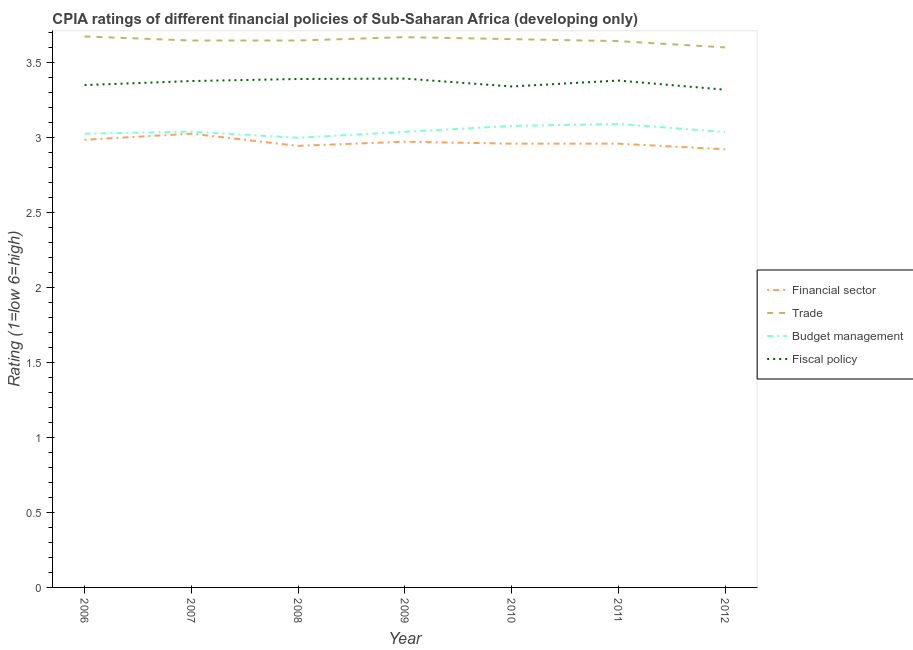How many different coloured lines are there?
Ensure brevity in your answer.  4. Is the number of lines equal to the number of legend labels?
Provide a short and direct response. Yes. What is the cpia rating of budget management in 2010?
Provide a short and direct response. 3.08. Across all years, what is the maximum cpia rating of financial sector?
Provide a succinct answer. 3.03. Across all years, what is the minimum cpia rating of financial sector?
Your response must be concise. 2.92. In which year was the cpia rating of fiscal policy maximum?
Keep it short and to the point. 2009. In which year was the cpia rating of budget management minimum?
Keep it short and to the point. 2008. What is the total cpia rating of financial sector in the graph?
Give a very brief answer. 20.78. What is the difference between the cpia rating of fiscal policy in 2007 and that in 2009?
Your response must be concise. -0.02. What is the difference between the cpia rating of trade in 2009 and the cpia rating of financial sector in 2010?
Your answer should be compact. 0.71. What is the average cpia rating of trade per year?
Offer a terse response. 3.65. In the year 2006, what is the difference between the cpia rating of fiscal policy and cpia rating of budget management?
Your response must be concise. 0.32. In how many years, is the cpia rating of budget management greater than 2.2?
Keep it short and to the point. 7. What is the ratio of the cpia rating of fiscal policy in 2009 to that in 2011?
Make the answer very short. 1. Is the cpia rating of financial sector in 2010 less than that in 2011?
Your response must be concise. No. Is the difference between the cpia rating of trade in 2006 and 2009 greater than the difference between the cpia rating of financial sector in 2006 and 2009?
Provide a succinct answer. No. What is the difference between the highest and the second highest cpia rating of fiscal policy?
Keep it short and to the point. 0. What is the difference between the highest and the lowest cpia rating of financial sector?
Give a very brief answer. 0.1. In how many years, is the cpia rating of trade greater than the average cpia rating of trade taken over all years?
Ensure brevity in your answer.  3. Is the sum of the cpia rating of financial sector in 2009 and 2010 greater than the maximum cpia rating of trade across all years?
Keep it short and to the point. Yes. Is the cpia rating of budget management strictly greater than the cpia rating of fiscal policy over the years?
Your answer should be compact. No. How many lines are there?
Offer a very short reply. 4. How many years are there in the graph?
Ensure brevity in your answer.  7. Does the graph contain grids?
Offer a terse response. No. Where does the legend appear in the graph?
Your answer should be very brief. Center right. What is the title of the graph?
Ensure brevity in your answer.  CPIA ratings of different financial policies of Sub-Saharan Africa (developing only). What is the label or title of the Y-axis?
Provide a short and direct response. Rating (1=low 6=high). What is the Rating (1=low 6=high) in Financial sector in 2006?
Provide a succinct answer. 2.99. What is the Rating (1=low 6=high) in Trade in 2006?
Provide a short and direct response. 3.68. What is the Rating (1=low 6=high) in Budget management in 2006?
Your answer should be very brief. 3.03. What is the Rating (1=low 6=high) of Fiscal policy in 2006?
Make the answer very short. 3.35. What is the Rating (1=low 6=high) of Financial sector in 2007?
Your response must be concise. 3.03. What is the Rating (1=low 6=high) in Trade in 2007?
Keep it short and to the point. 3.65. What is the Rating (1=low 6=high) in Budget management in 2007?
Your answer should be very brief. 3.04. What is the Rating (1=low 6=high) of Fiscal policy in 2007?
Your answer should be compact. 3.38. What is the Rating (1=low 6=high) of Financial sector in 2008?
Keep it short and to the point. 2.95. What is the Rating (1=low 6=high) of Trade in 2008?
Offer a very short reply. 3.65. What is the Rating (1=low 6=high) in Budget management in 2008?
Ensure brevity in your answer.  3. What is the Rating (1=low 6=high) of Fiscal policy in 2008?
Your answer should be very brief. 3.39. What is the Rating (1=low 6=high) of Financial sector in 2009?
Give a very brief answer. 2.97. What is the Rating (1=low 6=high) in Trade in 2009?
Your answer should be compact. 3.67. What is the Rating (1=low 6=high) in Budget management in 2009?
Ensure brevity in your answer.  3.04. What is the Rating (1=low 6=high) of Fiscal policy in 2009?
Offer a very short reply. 3.39. What is the Rating (1=low 6=high) in Financial sector in 2010?
Your answer should be very brief. 2.96. What is the Rating (1=low 6=high) of Trade in 2010?
Provide a succinct answer. 3.66. What is the Rating (1=low 6=high) in Budget management in 2010?
Offer a very short reply. 3.08. What is the Rating (1=low 6=high) of Fiscal policy in 2010?
Your answer should be very brief. 3.34. What is the Rating (1=low 6=high) in Financial sector in 2011?
Provide a succinct answer. 2.96. What is the Rating (1=low 6=high) of Trade in 2011?
Offer a very short reply. 3.64. What is the Rating (1=low 6=high) of Budget management in 2011?
Your answer should be very brief. 3.09. What is the Rating (1=low 6=high) in Fiscal policy in 2011?
Make the answer very short. 3.38. What is the Rating (1=low 6=high) in Financial sector in 2012?
Your answer should be compact. 2.92. What is the Rating (1=low 6=high) in Trade in 2012?
Your answer should be very brief. 3.6. What is the Rating (1=low 6=high) in Budget management in 2012?
Your answer should be very brief. 3.04. What is the Rating (1=low 6=high) in Fiscal policy in 2012?
Your answer should be compact. 3.32. Across all years, what is the maximum Rating (1=low 6=high) of Financial sector?
Your answer should be very brief. 3.03. Across all years, what is the maximum Rating (1=low 6=high) in Trade?
Make the answer very short. 3.68. Across all years, what is the maximum Rating (1=low 6=high) of Budget management?
Offer a very short reply. 3.09. Across all years, what is the maximum Rating (1=low 6=high) in Fiscal policy?
Keep it short and to the point. 3.39. Across all years, what is the minimum Rating (1=low 6=high) of Financial sector?
Your response must be concise. 2.92. Across all years, what is the minimum Rating (1=low 6=high) of Trade?
Make the answer very short. 3.6. Across all years, what is the minimum Rating (1=low 6=high) of Fiscal policy?
Make the answer very short. 3.32. What is the total Rating (1=low 6=high) of Financial sector in the graph?
Your answer should be very brief. 20.78. What is the total Rating (1=low 6=high) of Trade in the graph?
Offer a very short reply. 25.55. What is the total Rating (1=low 6=high) of Budget management in the graph?
Your response must be concise. 21.32. What is the total Rating (1=low 6=high) in Fiscal policy in the graph?
Offer a very short reply. 23.56. What is the difference between the Rating (1=low 6=high) of Financial sector in 2006 and that in 2007?
Make the answer very short. -0.04. What is the difference between the Rating (1=low 6=high) in Trade in 2006 and that in 2007?
Your answer should be very brief. 0.03. What is the difference between the Rating (1=low 6=high) of Budget management in 2006 and that in 2007?
Provide a succinct answer. -0.01. What is the difference between the Rating (1=low 6=high) of Fiscal policy in 2006 and that in 2007?
Offer a terse response. -0.03. What is the difference between the Rating (1=low 6=high) of Financial sector in 2006 and that in 2008?
Keep it short and to the point. 0.04. What is the difference between the Rating (1=low 6=high) of Trade in 2006 and that in 2008?
Provide a succinct answer. 0.03. What is the difference between the Rating (1=low 6=high) of Budget management in 2006 and that in 2008?
Ensure brevity in your answer.  0.03. What is the difference between the Rating (1=low 6=high) in Fiscal policy in 2006 and that in 2008?
Provide a short and direct response. -0.04. What is the difference between the Rating (1=low 6=high) of Financial sector in 2006 and that in 2009?
Keep it short and to the point. 0.01. What is the difference between the Rating (1=low 6=high) of Trade in 2006 and that in 2009?
Provide a short and direct response. 0. What is the difference between the Rating (1=low 6=high) in Budget management in 2006 and that in 2009?
Your response must be concise. -0.01. What is the difference between the Rating (1=low 6=high) of Fiscal policy in 2006 and that in 2009?
Make the answer very short. -0.04. What is the difference between the Rating (1=low 6=high) of Financial sector in 2006 and that in 2010?
Provide a short and direct response. 0.03. What is the difference between the Rating (1=low 6=high) of Trade in 2006 and that in 2010?
Provide a short and direct response. 0.02. What is the difference between the Rating (1=low 6=high) in Budget management in 2006 and that in 2010?
Offer a terse response. -0.05. What is the difference between the Rating (1=low 6=high) in Fiscal policy in 2006 and that in 2010?
Offer a very short reply. 0.01. What is the difference between the Rating (1=low 6=high) of Financial sector in 2006 and that in 2011?
Your answer should be compact. 0.03. What is the difference between the Rating (1=low 6=high) in Trade in 2006 and that in 2011?
Offer a terse response. 0.03. What is the difference between the Rating (1=low 6=high) of Budget management in 2006 and that in 2011?
Give a very brief answer. -0.07. What is the difference between the Rating (1=low 6=high) of Fiscal policy in 2006 and that in 2011?
Offer a terse response. -0.03. What is the difference between the Rating (1=low 6=high) in Financial sector in 2006 and that in 2012?
Offer a very short reply. 0.06. What is the difference between the Rating (1=low 6=high) of Trade in 2006 and that in 2012?
Ensure brevity in your answer.  0.07. What is the difference between the Rating (1=low 6=high) in Budget management in 2006 and that in 2012?
Provide a short and direct response. -0.01. What is the difference between the Rating (1=low 6=high) in Fiscal policy in 2006 and that in 2012?
Offer a terse response. 0.03. What is the difference between the Rating (1=low 6=high) in Financial sector in 2007 and that in 2008?
Ensure brevity in your answer.  0.08. What is the difference between the Rating (1=low 6=high) of Budget management in 2007 and that in 2008?
Offer a terse response. 0.04. What is the difference between the Rating (1=low 6=high) of Fiscal policy in 2007 and that in 2008?
Your response must be concise. -0.01. What is the difference between the Rating (1=low 6=high) in Financial sector in 2007 and that in 2009?
Make the answer very short. 0.05. What is the difference between the Rating (1=low 6=high) in Trade in 2007 and that in 2009?
Your response must be concise. -0.02. What is the difference between the Rating (1=low 6=high) of Budget management in 2007 and that in 2009?
Make the answer very short. 0. What is the difference between the Rating (1=low 6=high) in Fiscal policy in 2007 and that in 2009?
Give a very brief answer. -0.02. What is the difference between the Rating (1=low 6=high) of Financial sector in 2007 and that in 2010?
Your response must be concise. 0.07. What is the difference between the Rating (1=low 6=high) of Trade in 2007 and that in 2010?
Keep it short and to the point. -0.01. What is the difference between the Rating (1=low 6=high) in Budget management in 2007 and that in 2010?
Provide a short and direct response. -0.04. What is the difference between the Rating (1=low 6=high) in Fiscal policy in 2007 and that in 2010?
Your answer should be compact. 0.04. What is the difference between the Rating (1=low 6=high) of Financial sector in 2007 and that in 2011?
Your response must be concise. 0.07. What is the difference between the Rating (1=low 6=high) of Trade in 2007 and that in 2011?
Your answer should be very brief. 0. What is the difference between the Rating (1=low 6=high) in Budget management in 2007 and that in 2011?
Offer a very short reply. -0.05. What is the difference between the Rating (1=low 6=high) in Fiscal policy in 2007 and that in 2011?
Your answer should be compact. -0. What is the difference between the Rating (1=low 6=high) in Financial sector in 2007 and that in 2012?
Your answer should be very brief. 0.1. What is the difference between the Rating (1=low 6=high) of Trade in 2007 and that in 2012?
Your answer should be compact. 0.05. What is the difference between the Rating (1=low 6=high) in Budget management in 2007 and that in 2012?
Ensure brevity in your answer.  0. What is the difference between the Rating (1=low 6=high) of Fiscal policy in 2007 and that in 2012?
Your answer should be very brief. 0.06. What is the difference between the Rating (1=low 6=high) in Financial sector in 2008 and that in 2009?
Keep it short and to the point. -0.03. What is the difference between the Rating (1=low 6=high) in Trade in 2008 and that in 2009?
Ensure brevity in your answer.  -0.02. What is the difference between the Rating (1=low 6=high) in Budget management in 2008 and that in 2009?
Your answer should be very brief. -0.04. What is the difference between the Rating (1=low 6=high) in Fiscal policy in 2008 and that in 2009?
Keep it short and to the point. -0. What is the difference between the Rating (1=low 6=high) of Financial sector in 2008 and that in 2010?
Keep it short and to the point. -0.01. What is the difference between the Rating (1=low 6=high) of Trade in 2008 and that in 2010?
Make the answer very short. -0.01. What is the difference between the Rating (1=low 6=high) of Budget management in 2008 and that in 2010?
Provide a succinct answer. -0.08. What is the difference between the Rating (1=low 6=high) in Fiscal policy in 2008 and that in 2010?
Offer a very short reply. 0.05. What is the difference between the Rating (1=low 6=high) of Financial sector in 2008 and that in 2011?
Make the answer very short. -0.01. What is the difference between the Rating (1=low 6=high) of Trade in 2008 and that in 2011?
Make the answer very short. 0. What is the difference between the Rating (1=low 6=high) in Budget management in 2008 and that in 2011?
Give a very brief answer. -0.09. What is the difference between the Rating (1=low 6=high) of Fiscal policy in 2008 and that in 2011?
Provide a succinct answer. 0.01. What is the difference between the Rating (1=low 6=high) of Financial sector in 2008 and that in 2012?
Keep it short and to the point. 0.02. What is the difference between the Rating (1=low 6=high) of Trade in 2008 and that in 2012?
Your response must be concise. 0.05. What is the difference between the Rating (1=low 6=high) in Budget management in 2008 and that in 2012?
Ensure brevity in your answer.  -0.04. What is the difference between the Rating (1=low 6=high) of Fiscal policy in 2008 and that in 2012?
Offer a very short reply. 0.07. What is the difference between the Rating (1=low 6=high) in Financial sector in 2009 and that in 2010?
Make the answer very short. 0.01. What is the difference between the Rating (1=low 6=high) in Trade in 2009 and that in 2010?
Your response must be concise. 0.01. What is the difference between the Rating (1=low 6=high) in Budget management in 2009 and that in 2010?
Ensure brevity in your answer.  -0.04. What is the difference between the Rating (1=low 6=high) of Fiscal policy in 2009 and that in 2010?
Offer a terse response. 0.05. What is the difference between the Rating (1=low 6=high) in Financial sector in 2009 and that in 2011?
Provide a short and direct response. 0.01. What is the difference between the Rating (1=low 6=high) of Trade in 2009 and that in 2011?
Ensure brevity in your answer.  0.03. What is the difference between the Rating (1=low 6=high) in Budget management in 2009 and that in 2011?
Your answer should be very brief. -0.05. What is the difference between the Rating (1=low 6=high) of Fiscal policy in 2009 and that in 2011?
Provide a succinct answer. 0.01. What is the difference between the Rating (1=low 6=high) of Financial sector in 2009 and that in 2012?
Your answer should be compact. 0.05. What is the difference between the Rating (1=low 6=high) of Trade in 2009 and that in 2012?
Make the answer very short. 0.07. What is the difference between the Rating (1=low 6=high) in Fiscal policy in 2009 and that in 2012?
Ensure brevity in your answer.  0.07. What is the difference between the Rating (1=low 6=high) of Trade in 2010 and that in 2011?
Ensure brevity in your answer.  0.01. What is the difference between the Rating (1=low 6=high) of Budget management in 2010 and that in 2011?
Your response must be concise. -0.01. What is the difference between the Rating (1=low 6=high) of Fiscal policy in 2010 and that in 2011?
Provide a short and direct response. -0.04. What is the difference between the Rating (1=low 6=high) of Financial sector in 2010 and that in 2012?
Provide a short and direct response. 0.04. What is the difference between the Rating (1=low 6=high) in Trade in 2010 and that in 2012?
Provide a succinct answer. 0.06. What is the difference between the Rating (1=low 6=high) of Budget management in 2010 and that in 2012?
Keep it short and to the point. 0.04. What is the difference between the Rating (1=low 6=high) in Fiscal policy in 2010 and that in 2012?
Ensure brevity in your answer.  0.02. What is the difference between the Rating (1=low 6=high) in Financial sector in 2011 and that in 2012?
Offer a terse response. 0.04. What is the difference between the Rating (1=low 6=high) in Trade in 2011 and that in 2012?
Your response must be concise. 0.04. What is the difference between the Rating (1=low 6=high) of Budget management in 2011 and that in 2012?
Provide a succinct answer. 0.05. What is the difference between the Rating (1=low 6=high) of Fiscal policy in 2011 and that in 2012?
Keep it short and to the point. 0.06. What is the difference between the Rating (1=low 6=high) of Financial sector in 2006 and the Rating (1=low 6=high) of Trade in 2007?
Offer a terse response. -0.66. What is the difference between the Rating (1=low 6=high) of Financial sector in 2006 and the Rating (1=low 6=high) of Budget management in 2007?
Keep it short and to the point. -0.05. What is the difference between the Rating (1=low 6=high) of Financial sector in 2006 and the Rating (1=low 6=high) of Fiscal policy in 2007?
Give a very brief answer. -0.39. What is the difference between the Rating (1=low 6=high) in Trade in 2006 and the Rating (1=low 6=high) in Budget management in 2007?
Your response must be concise. 0.64. What is the difference between the Rating (1=low 6=high) in Trade in 2006 and the Rating (1=low 6=high) in Fiscal policy in 2007?
Your answer should be very brief. 0.3. What is the difference between the Rating (1=low 6=high) of Budget management in 2006 and the Rating (1=low 6=high) of Fiscal policy in 2007?
Offer a terse response. -0.35. What is the difference between the Rating (1=low 6=high) in Financial sector in 2006 and the Rating (1=low 6=high) in Trade in 2008?
Offer a terse response. -0.66. What is the difference between the Rating (1=low 6=high) of Financial sector in 2006 and the Rating (1=low 6=high) of Budget management in 2008?
Your response must be concise. -0.01. What is the difference between the Rating (1=low 6=high) in Financial sector in 2006 and the Rating (1=low 6=high) in Fiscal policy in 2008?
Keep it short and to the point. -0.41. What is the difference between the Rating (1=low 6=high) of Trade in 2006 and the Rating (1=low 6=high) of Budget management in 2008?
Ensure brevity in your answer.  0.68. What is the difference between the Rating (1=low 6=high) in Trade in 2006 and the Rating (1=low 6=high) in Fiscal policy in 2008?
Offer a terse response. 0.28. What is the difference between the Rating (1=low 6=high) of Budget management in 2006 and the Rating (1=low 6=high) of Fiscal policy in 2008?
Offer a very short reply. -0.36. What is the difference between the Rating (1=low 6=high) of Financial sector in 2006 and the Rating (1=low 6=high) of Trade in 2009?
Your answer should be compact. -0.68. What is the difference between the Rating (1=low 6=high) of Financial sector in 2006 and the Rating (1=low 6=high) of Budget management in 2009?
Offer a very short reply. -0.05. What is the difference between the Rating (1=low 6=high) in Financial sector in 2006 and the Rating (1=low 6=high) in Fiscal policy in 2009?
Your response must be concise. -0.41. What is the difference between the Rating (1=low 6=high) in Trade in 2006 and the Rating (1=low 6=high) in Budget management in 2009?
Keep it short and to the point. 0.64. What is the difference between the Rating (1=low 6=high) of Trade in 2006 and the Rating (1=low 6=high) of Fiscal policy in 2009?
Provide a short and direct response. 0.28. What is the difference between the Rating (1=low 6=high) in Budget management in 2006 and the Rating (1=low 6=high) in Fiscal policy in 2009?
Provide a short and direct response. -0.37. What is the difference between the Rating (1=low 6=high) of Financial sector in 2006 and the Rating (1=low 6=high) of Trade in 2010?
Provide a succinct answer. -0.67. What is the difference between the Rating (1=low 6=high) in Financial sector in 2006 and the Rating (1=low 6=high) in Budget management in 2010?
Provide a short and direct response. -0.09. What is the difference between the Rating (1=low 6=high) in Financial sector in 2006 and the Rating (1=low 6=high) in Fiscal policy in 2010?
Provide a succinct answer. -0.36. What is the difference between the Rating (1=low 6=high) in Trade in 2006 and the Rating (1=low 6=high) in Budget management in 2010?
Provide a short and direct response. 0.6. What is the difference between the Rating (1=low 6=high) of Trade in 2006 and the Rating (1=low 6=high) of Fiscal policy in 2010?
Keep it short and to the point. 0.33. What is the difference between the Rating (1=low 6=high) of Budget management in 2006 and the Rating (1=low 6=high) of Fiscal policy in 2010?
Your answer should be compact. -0.32. What is the difference between the Rating (1=low 6=high) in Financial sector in 2006 and the Rating (1=low 6=high) in Trade in 2011?
Provide a short and direct response. -0.66. What is the difference between the Rating (1=low 6=high) of Financial sector in 2006 and the Rating (1=low 6=high) of Budget management in 2011?
Provide a short and direct response. -0.11. What is the difference between the Rating (1=low 6=high) in Financial sector in 2006 and the Rating (1=low 6=high) in Fiscal policy in 2011?
Ensure brevity in your answer.  -0.4. What is the difference between the Rating (1=low 6=high) in Trade in 2006 and the Rating (1=low 6=high) in Budget management in 2011?
Your response must be concise. 0.58. What is the difference between the Rating (1=low 6=high) in Trade in 2006 and the Rating (1=low 6=high) in Fiscal policy in 2011?
Give a very brief answer. 0.29. What is the difference between the Rating (1=low 6=high) in Budget management in 2006 and the Rating (1=low 6=high) in Fiscal policy in 2011?
Provide a short and direct response. -0.35. What is the difference between the Rating (1=low 6=high) in Financial sector in 2006 and the Rating (1=low 6=high) in Trade in 2012?
Keep it short and to the point. -0.62. What is the difference between the Rating (1=low 6=high) in Financial sector in 2006 and the Rating (1=low 6=high) in Budget management in 2012?
Keep it short and to the point. -0.05. What is the difference between the Rating (1=low 6=high) of Financial sector in 2006 and the Rating (1=low 6=high) of Fiscal policy in 2012?
Keep it short and to the point. -0.33. What is the difference between the Rating (1=low 6=high) of Trade in 2006 and the Rating (1=low 6=high) of Budget management in 2012?
Your answer should be very brief. 0.64. What is the difference between the Rating (1=low 6=high) in Trade in 2006 and the Rating (1=low 6=high) in Fiscal policy in 2012?
Offer a terse response. 0.36. What is the difference between the Rating (1=low 6=high) of Budget management in 2006 and the Rating (1=low 6=high) of Fiscal policy in 2012?
Offer a terse response. -0.29. What is the difference between the Rating (1=low 6=high) in Financial sector in 2007 and the Rating (1=low 6=high) in Trade in 2008?
Offer a very short reply. -0.62. What is the difference between the Rating (1=low 6=high) in Financial sector in 2007 and the Rating (1=low 6=high) in Budget management in 2008?
Provide a short and direct response. 0.03. What is the difference between the Rating (1=low 6=high) in Financial sector in 2007 and the Rating (1=low 6=high) in Fiscal policy in 2008?
Your answer should be compact. -0.36. What is the difference between the Rating (1=low 6=high) of Trade in 2007 and the Rating (1=low 6=high) of Budget management in 2008?
Provide a succinct answer. 0.65. What is the difference between the Rating (1=low 6=high) in Trade in 2007 and the Rating (1=low 6=high) in Fiscal policy in 2008?
Make the answer very short. 0.26. What is the difference between the Rating (1=low 6=high) of Budget management in 2007 and the Rating (1=low 6=high) of Fiscal policy in 2008?
Offer a terse response. -0.35. What is the difference between the Rating (1=low 6=high) in Financial sector in 2007 and the Rating (1=low 6=high) in Trade in 2009?
Give a very brief answer. -0.64. What is the difference between the Rating (1=low 6=high) of Financial sector in 2007 and the Rating (1=low 6=high) of Budget management in 2009?
Give a very brief answer. -0.01. What is the difference between the Rating (1=low 6=high) of Financial sector in 2007 and the Rating (1=low 6=high) of Fiscal policy in 2009?
Ensure brevity in your answer.  -0.37. What is the difference between the Rating (1=low 6=high) in Trade in 2007 and the Rating (1=low 6=high) in Budget management in 2009?
Your answer should be compact. 0.61. What is the difference between the Rating (1=low 6=high) in Trade in 2007 and the Rating (1=low 6=high) in Fiscal policy in 2009?
Your answer should be very brief. 0.25. What is the difference between the Rating (1=low 6=high) in Budget management in 2007 and the Rating (1=low 6=high) in Fiscal policy in 2009?
Offer a terse response. -0.35. What is the difference between the Rating (1=low 6=high) in Financial sector in 2007 and the Rating (1=low 6=high) in Trade in 2010?
Give a very brief answer. -0.63. What is the difference between the Rating (1=low 6=high) in Financial sector in 2007 and the Rating (1=low 6=high) in Budget management in 2010?
Give a very brief answer. -0.05. What is the difference between the Rating (1=low 6=high) in Financial sector in 2007 and the Rating (1=low 6=high) in Fiscal policy in 2010?
Your response must be concise. -0.32. What is the difference between the Rating (1=low 6=high) in Trade in 2007 and the Rating (1=low 6=high) in Budget management in 2010?
Your answer should be very brief. 0.57. What is the difference between the Rating (1=low 6=high) in Trade in 2007 and the Rating (1=low 6=high) in Fiscal policy in 2010?
Your response must be concise. 0.31. What is the difference between the Rating (1=low 6=high) in Budget management in 2007 and the Rating (1=low 6=high) in Fiscal policy in 2010?
Keep it short and to the point. -0.3. What is the difference between the Rating (1=low 6=high) in Financial sector in 2007 and the Rating (1=low 6=high) in Trade in 2011?
Ensure brevity in your answer.  -0.62. What is the difference between the Rating (1=low 6=high) of Financial sector in 2007 and the Rating (1=low 6=high) of Budget management in 2011?
Provide a short and direct response. -0.07. What is the difference between the Rating (1=low 6=high) of Financial sector in 2007 and the Rating (1=low 6=high) of Fiscal policy in 2011?
Your answer should be compact. -0.35. What is the difference between the Rating (1=low 6=high) in Trade in 2007 and the Rating (1=low 6=high) in Budget management in 2011?
Offer a terse response. 0.56. What is the difference between the Rating (1=low 6=high) in Trade in 2007 and the Rating (1=low 6=high) in Fiscal policy in 2011?
Make the answer very short. 0.27. What is the difference between the Rating (1=low 6=high) in Budget management in 2007 and the Rating (1=low 6=high) in Fiscal policy in 2011?
Your answer should be compact. -0.34. What is the difference between the Rating (1=low 6=high) in Financial sector in 2007 and the Rating (1=low 6=high) in Trade in 2012?
Your answer should be compact. -0.58. What is the difference between the Rating (1=low 6=high) of Financial sector in 2007 and the Rating (1=low 6=high) of Budget management in 2012?
Offer a very short reply. -0.01. What is the difference between the Rating (1=low 6=high) of Financial sector in 2007 and the Rating (1=low 6=high) of Fiscal policy in 2012?
Make the answer very short. -0.29. What is the difference between the Rating (1=low 6=high) in Trade in 2007 and the Rating (1=low 6=high) in Budget management in 2012?
Keep it short and to the point. 0.61. What is the difference between the Rating (1=low 6=high) of Trade in 2007 and the Rating (1=low 6=high) of Fiscal policy in 2012?
Provide a succinct answer. 0.33. What is the difference between the Rating (1=low 6=high) in Budget management in 2007 and the Rating (1=low 6=high) in Fiscal policy in 2012?
Provide a short and direct response. -0.28. What is the difference between the Rating (1=low 6=high) in Financial sector in 2008 and the Rating (1=low 6=high) in Trade in 2009?
Your answer should be compact. -0.73. What is the difference between the Rating (1=low 6=high) in Financial sector in 2008 and the Rating (1=low 6=high) in Budget management in 2009?
Your answer should be very brief. -0.09. What is the difference between the Rating (1=low 6=high) of Financial sector in 2008 and the Rating (1=low 6=high) of Fiscal policy in 2009?
Your response must be concise. -0.45. What is the difference between the Rating (1=low 6=high) of Trade in 2008 and the Rating (1=low 6=high) of Budget management in 2009?
Ensure brevity in your answer.  0.61. What is the difference between the Rating (1=low 6=high) in Trade in 2008 and the Rating (1=low 6=high) in Fiscal policy in 2009?
Offer a very short reply. 0.25. What is the difference between the Rating (1=low 6=high) of Budget management in 2008 and the Rating (1=low 6=high) of Fiscal policy in 2009?
Offer a very short reply. -0.39. What is the difference between the Rating (1=low 6=high) in Financial sector in 2008 and the Rating (1=low 6=high) in Trade in 2010?
Offer a very short reply. -0.71. What is the difference between the Rating (1=low 6=high) of Financial sector in 2008 and the Rating (1=low 6=high) of Budget management in 2010?
Provide a short and direct response. -0.13. What is the difference between the Rating (1=low 6=high) of Financial sector in 2008 and the Rating (1=low 6=high) of Fiscal policy in 2010?
Provide a succinct answer. -0.4. What is the difference between the Rating (1=low 6=high) in Trade in 2008 and the Rating (1=low 6=high) in Budget management in 2010?
Keep it short and to the point. 0.57. What is the difference between the Rating (1=low 6=high) in Trade in 2008 and the Rating (1=low 6=high) in Fiscal policy in 2010?
Provide a short and direct response. 0.31. What is the difference between the Rating (1=low 6=high) in Budget management in 2008 and the Rating (1=low 6=high) in Fiscal policy in 2010?
Your answer should be compact. -0.34. What is the difference between the Rating (1=low 6=high) of Financial sector in 2008 and the Rating (1=low 6=high) of Trade in 2011?
Provide a succinct answer. -0.7. What is the difference between the Rating (1=low 6=high) of Financial sector in 2008 and the Rating (1=low 6=high) of Budget management in 2011?
Offer a terse response. -0.15. What is the difference between the Rating (1=low 6=high) in Financial sector in 2008 and the Rating (1=low 6=high) in Fiscal policy in 2011?
Make the answer very short. -0.44. What is the difference between the Rating (1=low 6=high) of Trade in 2008 and the Rating (1=low 6=high) of Budget management in 2011?
Your answer should be very brief. 0.56. What is the difference between the Rating (1=low 6=high) in Trade in 2008 and the Rating (1=low 6=high) in Fiscal policy in 2011?
Give a very brief answer. 0.27. What is the difference between the Rating (1=low 6=high) in Budget management in 2008 and the Rating (1=low 6=high) in Fiscal policy in 2011?
Keep it short and to the point. -0.38. What is the difference between the Rating (1=low 6=high) in Financial sector in 2008 and the Rating (1=low 6=high) in Trade in 2012?
Provide a short and direct response. -0.66. What is the difference between the Rating (1=low 6=high) in Financial sector in 2008 and the Rating (1=low 6=high) in Budget management in 2012?
Your answer should be compact. -0.09. What is the difference between the Rating (1=low 6=high) of Financial sector in 2008 and the Rating (1=low 6=high) of Fiscal policy in 2012?
Offer a very short reply. -0.37. What is the difference between the Rating (1=low 6=high) of Trade in 2008 and the Rating (1=low 6=high) of Budget management in 2012?
Your answer should be compact. 0.61. What is the difference between the Rating (1=low 6=high) in Trade in 2008 and the Rating (1=low 6=high) in Fiscal policy in 2012?
Provide a short and direct response. 0.33. What is the difference between the Rating (1=low 6=high) in Budget management in 2008 and the Rating (1=low 6=high) in Fiscal policy in 2012?
Offer a terse response. -0.32. What is the difference between the Rating (1=low 6=high) in Financial sector in 2009 and the Rating (1=low 6=high) in Trade in 2010?
Your response must be concise. -0.68. What is the difference between the Rating (1=low 6=high) of Financial sector in 2009 and the Rating (1=low 6=high) of Budget management in 2010?
Offer a terse response. -0.11. What is the difference between the Rating (1=low 6=high) in Financial sector in 2009 and the Rating (1=low 6=high) in Fiscal policy in 2010?
Provide a short and direct response. -0.37. What is the difference between the Rating (1=low 6=high) of Trade in 2009 and the Rating (1=low 6=high) of Budget management in 2010?
Offer a terse response. 0.59. What is the difference between the Rating (1=low 6=high) of Trade in 2009 and the Rating (1=low 6=high) of Fiscal policy in 2010?
Offer a terse response. 0.33. What is the difference between the Rating (1=low 6=high) of Budget management in 2009 and the Rating (1=low 6=high) of Fiscal policy in 2010?
Provide a succinct answer. -0.3. What is the difference between the Rating (1=low 6=high) in Financial sector in 2009 and the Rating (1=low 6=high) in Trade in 2011?
Provide a short and direct response. -0.67. What is the difference between the Rating (1=low 6=high) in Financial sector in 2009 and the Rating (1=low 6=high) in Budget management in 2011?
Give a very brief answer. -0.12. What is the difference between the Rating (1=low 6=high) in Financial sector in 2009 and the Rating (1=low 6=high) in Fiscal policy in 2011?
Offer a very short reply. -0.41. What is the difference between the Rating (1=low 6=high) in Trade in 2009 and the Rating (1=low 6=high) in Budget management in 2011?
Provide a short and direct response. 0.58. What is the difference between the Rating (1=low 6=high) in Trade in 2009 and the Rating (1=low 6=high) in Fiscal policy in 2011?
Ensure brevity in your answer.  0.29. What is the difference between the Rating (1=low 6=high) of Budget management in 2009 and the Rating (1=low 6=high) of Fiscal policy in 2011?
Offer a terse response. -0.34. What is the difference between the Rating (1=low 6=high) of Financial sector in 2009 and the Rating (1=low 6=high) of Trade in 2012?
Keep it short and to the point. -0.63. What is the difference between the Rating (1=low 6=high) in Financial sector in 2009 and the Rating (1=low 6=high) in Budget management in 2012?
Your answer should be very brief. -0.06. What is the difference between the Rating (1=low 6=high) of Financial sector in 2009 and the Rating (1=low 6=high) of Fiscal policy in 2012?
Keep it short and to the point. -0.35. What is the difference between the Rating (1=low 6=high) in Trade in 2009 and the Rating (1=low 6=high) in Budget management in 2012?
Your answer should be very brief. 0.63. What is the difference between the Rating (1=low 6=high) in Trade in 2009 and the Rating (1=low 6=high) in Fiscal policy in 2012?
Offer a terse response. 0.35. What is the difference between the Rating (1=low 6=high) of Budget management in 2009 and the Rating (1=low 6=high) of Fiscal policy in 2012?
Provide a short and direct response. -0.28. What is the difference between the Rating (1=low 6=high) of Financial sector in 2010 and the Rating (1=low 6=high) of Trade in 2011?
Your answer should be compact. -0.68. What is the difference between the Rating (1=low 6=high) of Financial sector in 2010 and the Rating (1=low 6=high) of Budget management in 2011?
Ensure brevity in your answer.  -0.13. What is the difference between the Rating (1=low 6=high) of Financial sector in 2010 and the Rating (1=low 6=high) of Fiscal policy in 2011?
Keep it short and to the point. -0.42. What is the difference between the Rating (1=low 6=high) of Trade in 2010 and the Rating (1=low 6=high) of Budget management in 2011?
Give a very brief answer. 0.57. What is the difference between the Rating (1=low 6=high) of Trade in 2010 and the Rating (1=low 6=high) of Fiscal policy in 2011?
Provide a succinct answer. 0.28. What is the difference between the Rating (1=low 6=high) of Budget management in 2010 and the Rating (1=low 6=high) of Fiscal policy in 2011?
Your answer should be compact. -0.3. What is the difference between the Rating (1=low 6=high) in Financial sector in 2010 and the Rating (1=low 6=high) in Trade in 2012?
Your response must be concise. -0.64. What is the difference between the Rating (1=low 6=high) of Financial sector in 2010 and the Rating (1=low 6=high) of Budget management in 2012?
Ensure brevity in your answer.  -0.08. What is the difference between the Rating (1=low 6=high) in Financial sector in 2010 and the Rating (1=low 6=high) in Fiscal policy in 2012?
Offer a terse response. -0.36. What is the difference between the Rating (1=low 6=high) of Trade in 2010 and the Rating (1=low 6=high) of Budget management in 2012?
Keep it short and to the point. 0.62. What is the difference between the Rating (1=low 6=high) in Trade in 2010 and the Rating (1=low 6=high) in Fiscal policy in 2012?
Provide a succinct answer. 0.34. What is the difference between the Rating (1=low 6=high) in Budget management in 2010 and the Rating (1=low 6=high) in Fiscal policy in 2012?
Make the answer very short. -0.24. What is the difference between the Rating (1=low 6=high) in Financial sector in 2011 and the Rating (1=low 6=high) in Trade in 2012?
Offer a terse response. -0.64. What is the difference between the Rating (1=low 6=high) in Financial sector in 2011 and the Rating (1=low 6=high) in Budget management in 2012?
Your answer should be very brief. -0.08. What is the difference between the Rating (1=low 6=high) in Financial sector in 2011 and the Rating (1=low 6=high) in Fiscal policy in 2012?
Offer a very short reply. -0.36. What is the difference between the Rating (1=low 6=high) of Trade in 2011 and the Rating (1=low 6=high) of Budget management in 2012?
Provide a short and direct response. 0.61. What is the difference between the Rating (1=low 6=high) of Trade in 2011 and the Rating (1=low 6=high) of Fiscal policy in 2012?
Keep it short and to the point. 0.32. What is the difference between the Rating (1=low 6=high) of Budget management in 2011 and the Rating (1=low 6=high) of Fiscal policy in 2012?
Your answer should be very brief. -0.23. What is the average Rating (1=low 6=high) in Financial sector per year?
Make the answer very short. 2.97. What is the average Rating (1=low 6=high) of Trade per year?
Keep it short and to the point. 3.65. What is the average Rating (1=low 6=high) in Budget management per year?
Make the answer very short. 3.05. What is the average Rating (1=low 6=high) of Fiscal policy per year?
Your answer should be very brief. 3.37. In the year 2006, what is the difference between the Rating (1=low 6=high) in Financial sector and Rating (1=low 6=high) in Trade?
Provide a succinct answer. -0.69. In the year 2006, what is the difference between the Rating (1=low 6=high) of Financial sector and Rating (1=low 6=high) of Budget management?
Give a very brief answer. -0.04. In the year 2006, what is the difference between the Rating (1=low 6=high) of Financial sector and Rating (1=low 6=high) of Fiscal policy?
Keep it short and to the point. -0.36. In the year 2006, what is the difference between the Rating (1=low 6=high) of Trade and Rating (1=low 6=high) of Budget management?
Your response must be concise. 0.65. In the year 2006, what is the difference between the Rating (1=low 6=high) in Trade and Rating (1=low 6=high) in Fiscal policy?
Keep it short and to the point. 0.32. In the year 2006, what is the difference between the Rating (1=low 6=high) of Budget management and Rating (1=low 6=high) of Fiscal policy?
Your answer should be compact. -0.32. In the year 2007, what is the difference between the Rating (1=low 6=high) in Financial sector and Rating (1=low 6=high) in Trade?
Provide a short and direct response. -0.62. In the year 2007, what is the difference between the Rating (1=low 6=high) of Financial sector and Rating (1=low 6=high) of Budget management?
Your answer should be very brief. -0.01. In the year 2007, what is the difference between the Rating (1=low 6=high) of Financial sector and Rating (1=low 6=high) of Fiscal policy?
Offer a very short reply. -0.35. In the year 2007, what is the difference between the Rating (1=low 6=high) of Trade and Rating (1=low 6=high) of Budget management?
Ensure brevity in your answer.  0.61. In the year 2007, what is the difference between the Rating (1=low 6=high) in Trade and Rating (1=low 6=high) in Fiscal policy?
Your response must be concise. 0.27. In the year 2007, what is the difference between the Rating (1=low 6=high) in Budget management and Rating (1=low 6=high) in Fiscal policy?
Your answer should be very brief. -0.34. In the year 2008, what is the difference between the Rating (1=low 6=high) of Financial sector and Rating (1=low 6=high) of Trade?
Provide a short and direct response. -0.7. In the year 2008, what is the difference between the Rating (1=low 6=high) in Financial sector and Rating (1=low 6=high) in Budget management?
Provide a short and direct response. -0.05. In the year 2008, what is the difference between the Rating (1=low 6=high) in Financial sector and Rating (1=low 6=high) in Fiscal policy?
Offer a very short reply. -0.45. In the year 2008, what is the difference between the Rating (1=low 6=high) in Trade and Rating (1=low 6=high) in Budget management?
Your answer should be very brief. 0.65. In the year 2008, what is the difference between the Rating (1=low 6=high) in Trade and Rating (1=low 6=high) in Fiscal policy?
Your answer should be compact. 0.26. In the year 2008, what is the difference between the Rating (1=low 6=high) in Budget management and Rating (1=low 6=high) in Fiscal policy?
Ensure brevity in your answer.  -0.39. In the year 2009, what is the difference between the Rating (1=low 6=high) of Financial sector and Rating (1=low 6=high) of Trade?
Your response must be concise. -0.7. In the year 2009, what is the difference between the Rating (1=low 6=high) of Financial sector and Rating (1=low 6=high) of Budget management?
Your answer should be very brief. -0.07. In the year 2009, what is the difference between the Rating (1=low 6=high) in Financial sector and Rating (1=low 6=high) in Fiscal policy?
Make the answer very short. -0.42. In the year 2009, what is the difference between the Rating (1=low 6=high) in Trade and Rating (1=low 6=high) in Budget management?
Offer a terse response. 0.63. In the year 2009, what is the difference between the Rating (1=low 6=high) of Trade and Rating (1=low 6=high) of Fiscal policy?
Your answer should be compact. 0.28. In the year 2009, what is the difference between the Rating (1=low 6=high) in Budget management and Rating (1=low 6=high) in Fiscal policy?
Your answer should be compact. -0.36. In the year 2010, what is the difference between the Rating (1=low 6=high) in Financial sector and Rating (1=low 6=high) in Trade?
Ensure brevity in your answer.  -0.7. In the year 2010, what is the difference between the Rating (1=low 6=high) in Financial sector and Rating (1=low 6=high) in Budget management?
Offer a very short reply. -0.12. In the year 2010, what is the difference between the Rating (1=low 6=high) in Financial sector and Rating (1=low 6=high) in Fiscal policy?
Your response must be concise. -0.38. In the year 2010, what is the difference between the Rating (1=low 6=high) of Trade and Rating (1=low 6=high) of Budget management?
Your response must be concise. 0.58. In the year 2010, what is the difference between the Rating (1=low 6=high) of Trade and Rating (1=low 6=high) of Fiscal policy?
Offer a very short reply. 0.32. In the year 2010, what is the difference between the Rating (1=low 6=high) in Budget management and Rating (1=low 6=high) in Fiscal policy?
Your response must be concise. -0.26. In the year 2011, what is the difference between the Rating (1=low 6=high) of Financial sector and Rating (1=low 6=high) of Trade?
Provide a short and direct response. -0.68. In the year 2011, what is the difference between the Rating (1=low 6=high) in Financial sector and Rating (1=low 6=high) in Budget management?
Keep it short and to the point. -0.13. In the year 2011, what is the difference between the Rating (1=low 6=high) in Financial sector and Rating (1=low 6=high) in Fiscal policy?
Your answer should be very brief. -0.42. In the year 2011, what is the difference between the Rating (1=low 6=high) of Trade and Rating (1=low 6=high) of Budget management?
Make the answer very short. 0.55. In the year 2011, what is the difference between the Rating (1=low 6=high) of Trade and Rating (1=low 6=high) of Fiscal policy?
Your answer should be very brief. 0.26. In the year 2011, what is the difference between the Rating (1=low 6=high) in Budget management and Rating (1=low 6=high) in Fiscal policy?
Give a very brief answer. -0.29. In the year 2012, what is the difference between the Rating (1=low 6=high) of Financial sector and Rating (1=low 6=high) of Trade?
Offer a very short reply. -0.68. In the year 2012, what is the difference between the Rating (1=low 6=high) of Financial sector and Rating (1=low 6=high) of Budget management?
Give a very brief answer. -0.12. In the year 2012, what is the difference between the Rating (1=low 6=high) of Financial sector and Rating (1=low 6=high) of Fiscal policy?
Keep it short and to the point. -0.4. In the year 2012, what is the difference between the Rating (1=low 6=high) in Trade and Rating (1=low 6=high) in Budget management?
Keep it short and to the point. 0.56. In the year 2012, what is the difference between the Rating (1=low 6=high) in Trade and Rating (1=low 6=high) in Fiscal policy?
Offer a terse response. 0.28. In the year 2012, what is the difference between the Rating (1=low 6=high) of Budget management and Rating (1=low 6=high) of Fiscal policy?
Your response must be concise. -0.28. What is the ratio of the Rating (1=low 6=high) of Financial sector in 2006 to that in 2007?
Make the answer very short. 0.99. What is the ratio of the Rating (1=low 6=high) of Trade in 2006 to that in 2007?
Your answer should be very brief. 1.01. What is the ratio of the Rating (1=low 6=high) in Financial sector in 2006 to that in 2008?
Keep it short and to the point. 1.01. What is the ratio of the Rating (1=low 6=high) of Trade in 2006 to that in 2008?
Offer a very short reply. 1.01. What is the ratio of the Rating (1=low 6=high) of Budget management in 2006 to that in 2008?
Provide a succinct answer. 1.01. What is the ratio of the Rating (1=low 6=high) in Financial sector in 2006 to that in 2009?
Your response must be concise. 1. What is the ratio of the Rating (1=low 6=high) of Fiscal policy in 2006 to that in 2009?
Offer a very short reply. 0.99. What is the ratio of the Rating (1=low 6=high) in Financial sector in 2006 to that in 2010?
Offer a terse response. 1.01. What is the ratio of the Rating (1=low 6=high) of Budget management in 2006 to that in 2010?
Offer a terse response. 0.98. What is the ratio of the Rating (1=low 6=high) in Financial sector in 2006 to that in 2011?
Give a very brief answer. 1.01. What is the ratio of the Rating (1=low 6=high) in Trade in 2006 to that in 2011?
Keep it short and to the point. 1.01. What is the ratio of the Rating (1=low 6=high) of Financial sector in 2006 to that in 2012?
Provide a succinct answer. 1.02. What is the ratio of the Rating (1=low 6=high) in Trade in 2006 to that in 2012?
Offer a terse response. 1.02. What is the ratio of the Rating (1=low 6=high) in Budget management in 2006 to that in 2012?
Your response must be concise. 1. What is the ratio of the Rating (1=low 6=high) of Fiscal policy in 2006 to that in 2012?
Ensure brevity in your answer.  1.01. What is the ratio of the Rating (1=low 6=high) in Financial sector in 2007 to that in 2008?
Offer a terse response. 1.03. What is the ratio of the Rating (1=low 6=high) in Budget management in 2007 to that in 2008?
Your answer should be compact. 1.01. What is the ratio of the Rating (1=low 6=high) in Financial sector in 2007 to that in 2009?
Ensure brevity in your answer.  1.02. What is the ratio of the Rating (1=low 6=high) in Budget management in 2007 to that in 2009?
Give a very brief answer. 1. What is the ratio of the Rating (1=low 6=high) of Fiscal policy in 2007 to that in 2009?
Offer a terse response. 1. What is the ratio of the Rating (1=low 6=high) in Financial sector in 2007 to that in 2010?
Give a very brief answer. 1.02. What is the ratio of the Rating (1=low 6=high) in Trade in 2007 to that in 2010?
Give a very brief answer. 1. What is the ratio of the Rating (1=low 6=high) in Budget management in 2007 to that in 2010?
Offer a very short reply. 0.99. What is the ratio of the Rating (1=low 6=high) of Fiscal policy in 2007 to that in 2010?
Give a very brief answer. 1.01. What is the ratio of the Rating (1=low 6=high) in Financial sector in 2007 to that in 2011?
Provide a succinct answer. 1.02. What is the ratio of the Rating (1=low 6=high) in Trade in 2007 to that in 2011?
Offer a very short reply. 1. What is the ratio of the Rating (1=low 6=high) in Budget management in 2007 to that in 2011?
Your answer should be compact. 0.98. What is the ratio of the Rating (1=low 6=high) of Fiscal policy in 2007 to that in 2011?
Your answer should be very brief. 1. What is the ratio of the Rating (1=low 6=high) of Financial sector in 2007 to that in 2012?
Provide a succinct answer. 1.04. What is the ratio of the Rating (1=low 6=high) of Trade in 2007 to that in 2012?
Keep it short and to the point. 1.01. What is the ratio of the Rating (1=low 6=high) of Fiscal policy in 2007 to that in 2012?
Offer a terse response. 1.02. What is the ratio of the Rating (1=low 6=high) in Trade in 2008 to that in 2009?
Make the answer very short. 0.99. What is the ratio of the Rating (1=low 6=high) of Budget management in 2008 to that in 2010?
Offer a very short reply. 0.97. What is the ratio of the Rating (1=low 6=high) of Fiscal policy in 2008 to that in 2010?
Ensure brevity in your answer.  1.01. What is the ratio of the Rating (1=low 6=high) of Budget management in 2008 to that in 2011?
Ensure brevity in your answer.  0.97. What is the ratio of the Rating (1=low 6=high) in Trade in 2008 to that in 2012?
Provide a succinct answer. 1.01. What is the ratio of the Rating (1=low 6=high) in Budget management in 2008 to that in 2012?
Provide a short and direct response. 0.99. What is the ratio of the Rating (1=low 6=high) in Fiscal policy in 2008 to that in 2012?
Give a very brief answer. 1.02. What is the ratio of the Rating (1=low 6=high) in Financial sector in 2009 to that in 2010?
Ensure brevity in your answer.  1. What is the ratio of the Rating (1=low 6=high) of Budget management in 2009 to that in 2010?
Provide a short and direct response. 0.99. What is the ratio of the Rating (1=low 6=high) of Fiscal policy in 2009 to that in 2010?
Provide a succinct answer. 1.02. What is the ratio of the Rating (1=low 6=high) of Trade in 2009 to that in 2011?
Make the answer very short. 1.01. What is the ratio of the Rating (1=low 6=high) in Budget management in 2009 to that in 2011?
Give a very brief answer. 0.98. What is the ratio of the Rating (1=low 6=high) of Financial sector in 2009 to that in 2012?
Ensure brevity in your answer.  1.02. What is the ratio of the Rating (1=low 6=high) in Trade in 2009 to that in 2012?
Provide a short and direct response. 1.02. What is the ratio of the Rating (1=low 6=high) of Budget management in 2009 to that in 2012?
Offer a terse response. 1. What is the ratio of the Rating (1=low 6=high) in Fiscal policy in 2009 to that in 2012?
Ensure brevity in your answer.  1.02. What is the ratio of the Rating (1=low 6=high) in Financial sector in 2010 to that in 2011?
Provide a succinct answer. 1. What is the ratio of the Rating (1=low 6=high) in Trade in 2010 to that in 2011?
Give a very brief answer. 1. What is the ratio of the Rating (1=low 6=high) in Budget management in 2010 to that in 2011?
Offer a terse response. 1. What is the ratio of the Rating (1=low 6=high) in Fiscal policy in 2010 to that in 2011?
Offer a terse response. 0.99. What is the ratio of the Rating (1=low 6=high) in Financial sector in 2010 to that in 2012?
Ensure brevity in your answer.  1.01. What is the ratio of the Rating (1=low 6=high) of Trade in 2010 to that in 2012?
Your answer should be very brief. 1.02. What is the ratio of the Rating (1=low 6=high) in Budget management in 2010 to that in 2012?
Your answer should be very brief. 1.01. What is the ratio of the Rating (1=low 6=high) in Financial sector in 2011 to that in 2012?
Your answer should be compact. 1.01. What is the ratio of the Rating (1=low 6=high) in Trade in 2011 to that in 2012?
Give a very brief answer. 1.01. What is the ratio of the Rating (1=low 6=high) in Budget management in 2011 to that in 2012?
Your response must be concise. 1.02. What is the ratio of the Rating (1=low 6=high) in Fiscal policy in 2011 to that in 2012?
Give a very brief answer. 1.02. What is the difference between the highest and the second highest Rating (1=low 6=high) in Financial sector?
Offer a terse response. 0.04. What is the difference between the highest and the second highest Rating (1=low 6=high) of Trade?
Give a very brief answer. 0. What is the difference between the highest and the second highest Rating (1=low 6=high) in Budget management?
Make the answer very short. 0.01. What is the difference between the highest and the second highest Rating (1=low 6=high) in Fiscal policy?
Make the answer very short. 0. What is the difference between the highest and the lowest Rating (1=low 6=high) in Financial sector?
Provide a short and direct response. 0.1. What is the difference between the highest and the lowest Rating (1=low 6=high) of Trade?
Offer a very short reply. 0.07. What is the difference between the highest and the lowest Rating (1=low 6=high) in Budget management?
Offer a terse response. 0.09. What is the difference between the highest and the lowest Rating (1=low 6=high) of Fiscal policy?
Offer a terse response. 0.07. 